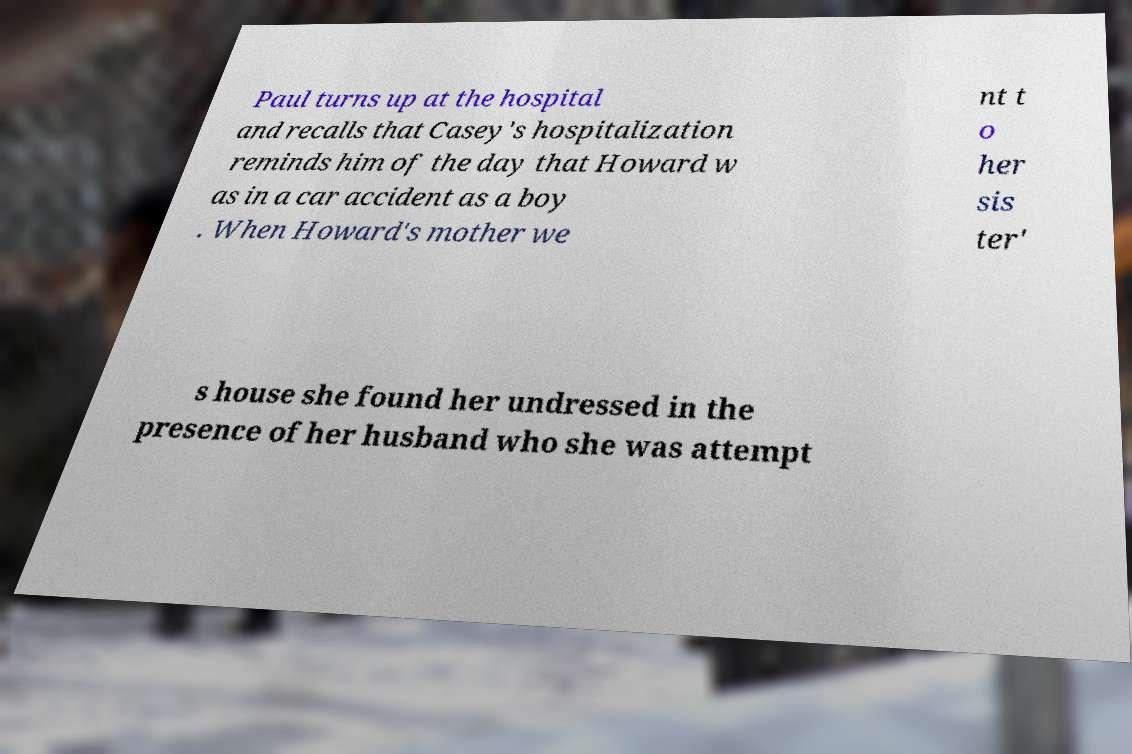Could you assist in decoding the text presented in this image and type it out clearly? Paul turns up at the hospital and recalls that Casey's hospitalization reminds him of the day that Howard w as in a car accident as a boy . When Howard's mother we nt t o her sis ter' s house she found her undressed in the presence of her husband who she was attempt 